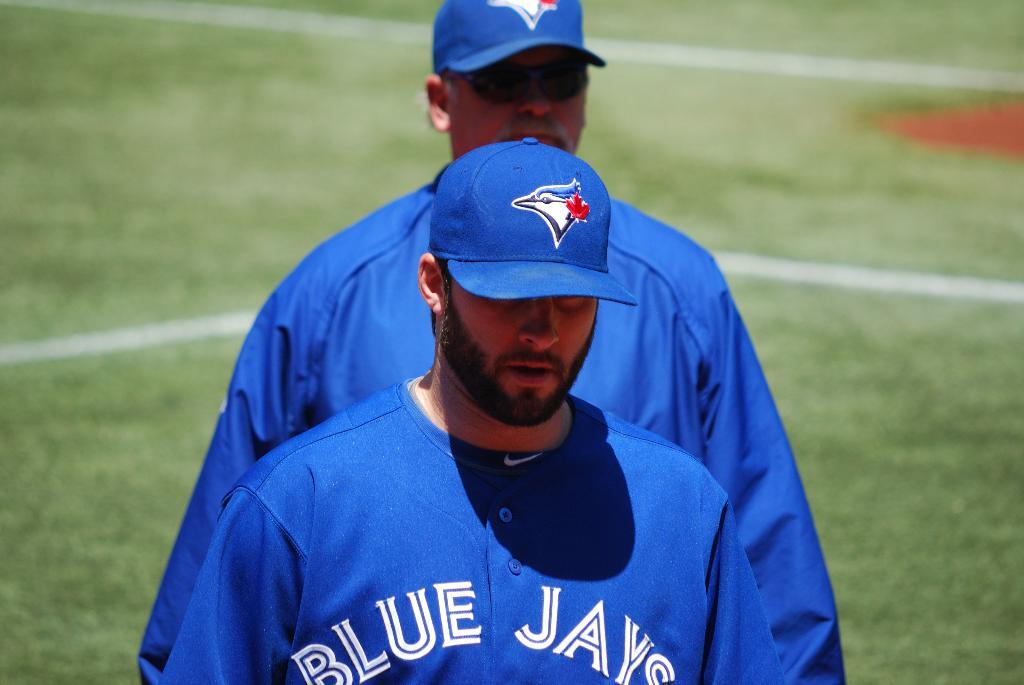<image>
Render a clear and concise summary of the photo. Two members of the Blue Jays stand on a sports field. 